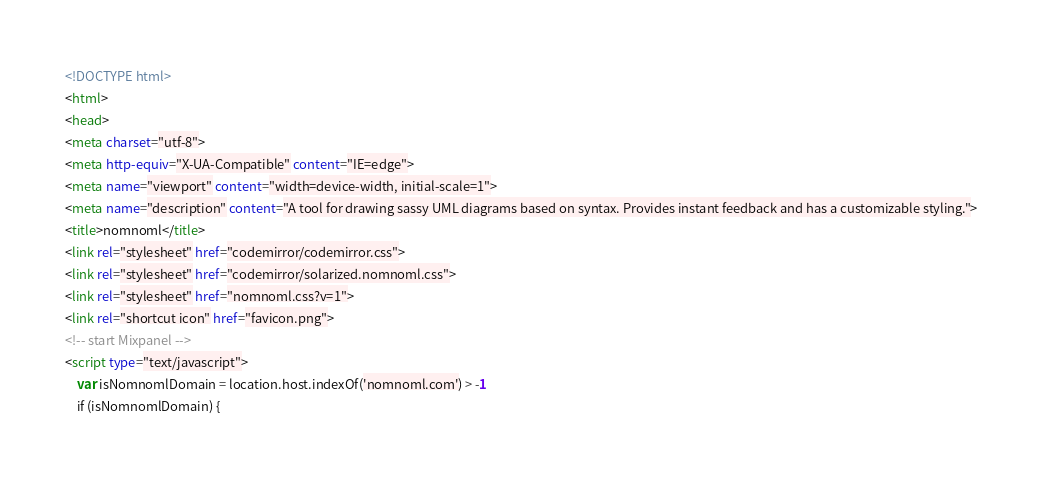Convert code to text. <code><loc_0><loc_0><loc_500><loc_500><_HTML_><!DOCTYPE html>
<html>
<head>
<meta charset="utf-8">
<meta http-equiv="X-UA-Compatible" content="IE=edge">
<meta name="viewport" content="width=device-width, initial-scale=1">
<meta name="description" content="A tool for drawing sassy UML diagrams based on syntax. Provides instant feedback and has a customizable styling.">
<title>nomnoml</title>
<link rel="stylesheet" href="codemirror/codemirror.css">
<link rel="stylesheet" href="codemirror/solarized.nomnoml.css">
<link rel="stylesheet" href="nomnoml.css?v=1">
<link rel="shortcut icon" href="favicon.png">
<!-- start Mixpanel -->
<script type="text/javascript">
	var isNomnomlDomain = location.host.indexOf('nomnoml.com') > -1
	if (isNomnomlDomain) {</code> 